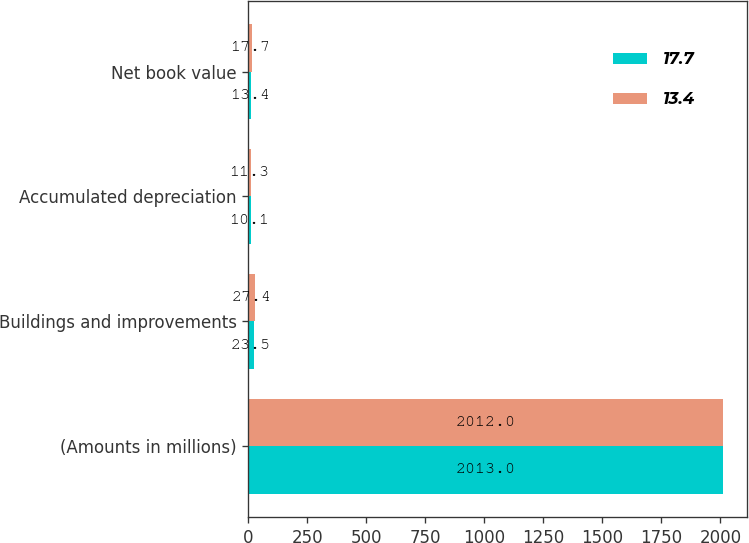<chart> <loc_0><loc_0><loc_500><loc_500><stacked_bar_chart><ecel><fcel>(Amounts in millions)<fcel>Buildings and improvements<fcel>Accumulated depreciation<fcel>Net book value<nl><fcel>17.7<fcel>2013<fcel>23.5<fcel>10.1<fcel>13.4<nl><fcel>13.4<fcel>2012<fcel>27.4<fcel>11.3<fcel>17.7<nl></chart> 